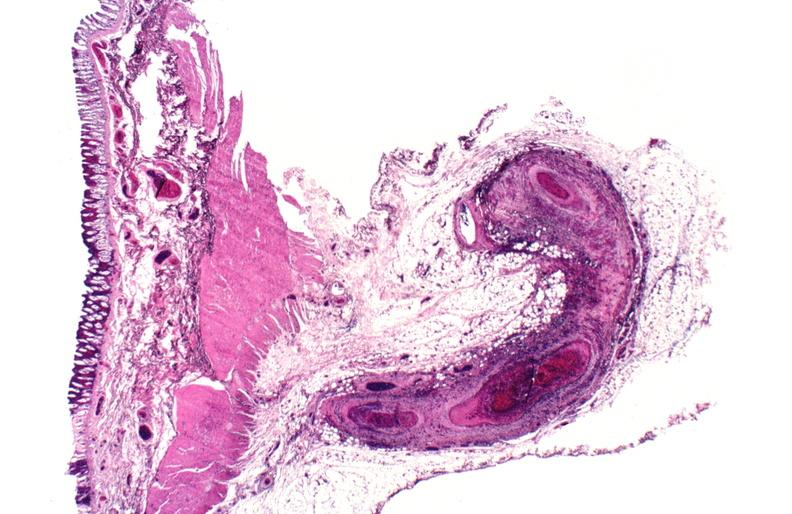what does this image show?
Answer the question using a single word or phrase. Polyarteritis nodosa 